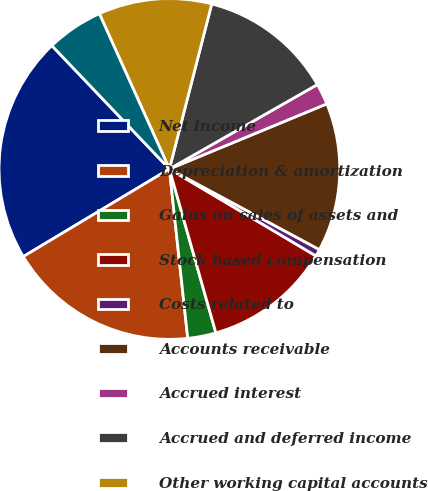Convert chart to OTSL. <chart><loc_0><loc_0><loc_500><loc_500><pie_chart><fcel>Net income<fcel>Depreciation & amortization<fcel>Gains on sales of assets and<fcel>Stock based compensation<fcel>Costs related to<fcel>Accounts receivable<fcel>Accrued interest<fcel>Accrued and deferred income<fcel>Other working capital accounts<fcel>Other assets and deferred<nl><fcel>21.48%<fcel>18.12%<fcel>2.68%<fcel>12.08%<fcel>0.67%<fcel>14.09%<fcel>2.01%<fcel>12.75%<fcel>10.74%<fcel>5.37%<nl></chart> 